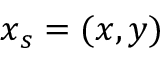Convert formula to latex. <formula><loc_0><loc_0><loc_500><loc_500>x _ { s } = ( x , y )</formula> 